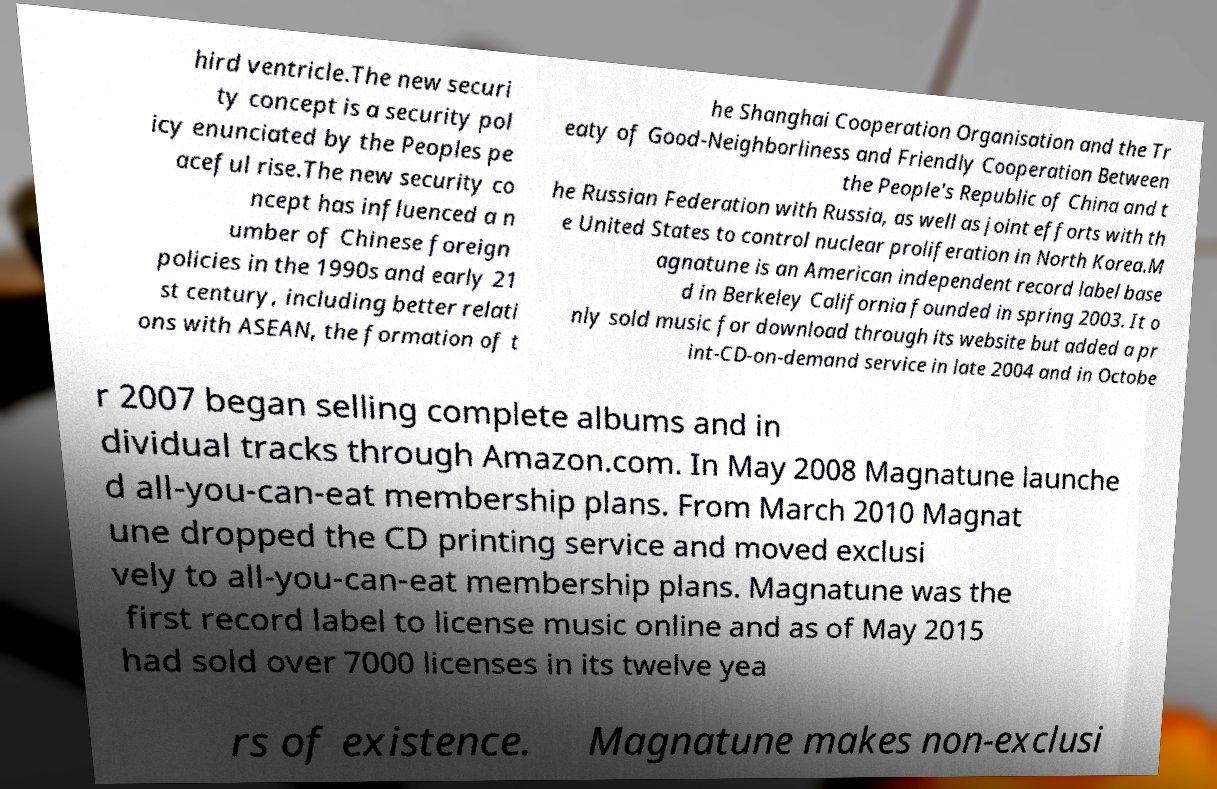I need the written content from this picture converted into text. Can you do that? hird ventricle.The new securi ty concept is a security pol icy enunciated by the Peoples pe aceful rise.The new security co ncept has influenced a n umber of Chinese foreign policies in the 1990s and early 21 st century, including better relati ons with ASEAN, the formation of t he Shanghai Cooperation Organisation and the Tr eaty of Good-Neighborliness and Friendly Cooperation Between the People's Republic of China and t he Russian Federation with Russia, as well as joint efforts with th e United States to control nuclear proliferation in North Korea.M agnatune is an American independent record label base d in Berkeley California founded in spring 2003. It o nly sold music for download through its website but added a pr int-CD-on-demand service in late 2004 and in Octobe r 2007 began selling complete albums and in dividual tracks through Amazon.com. In May 2008 Magnatune launche d all-you-can-eat membership plans. From March 2010 Magnat une dropped the CD printing service and moved exclusi vely to all-you-can-eat membership plans. Magnatune was the first record label to license music online and as of May 2015 had sold over 7000 licenses in its twelve yea rs of existence. Magnatune makes non-exclusi 